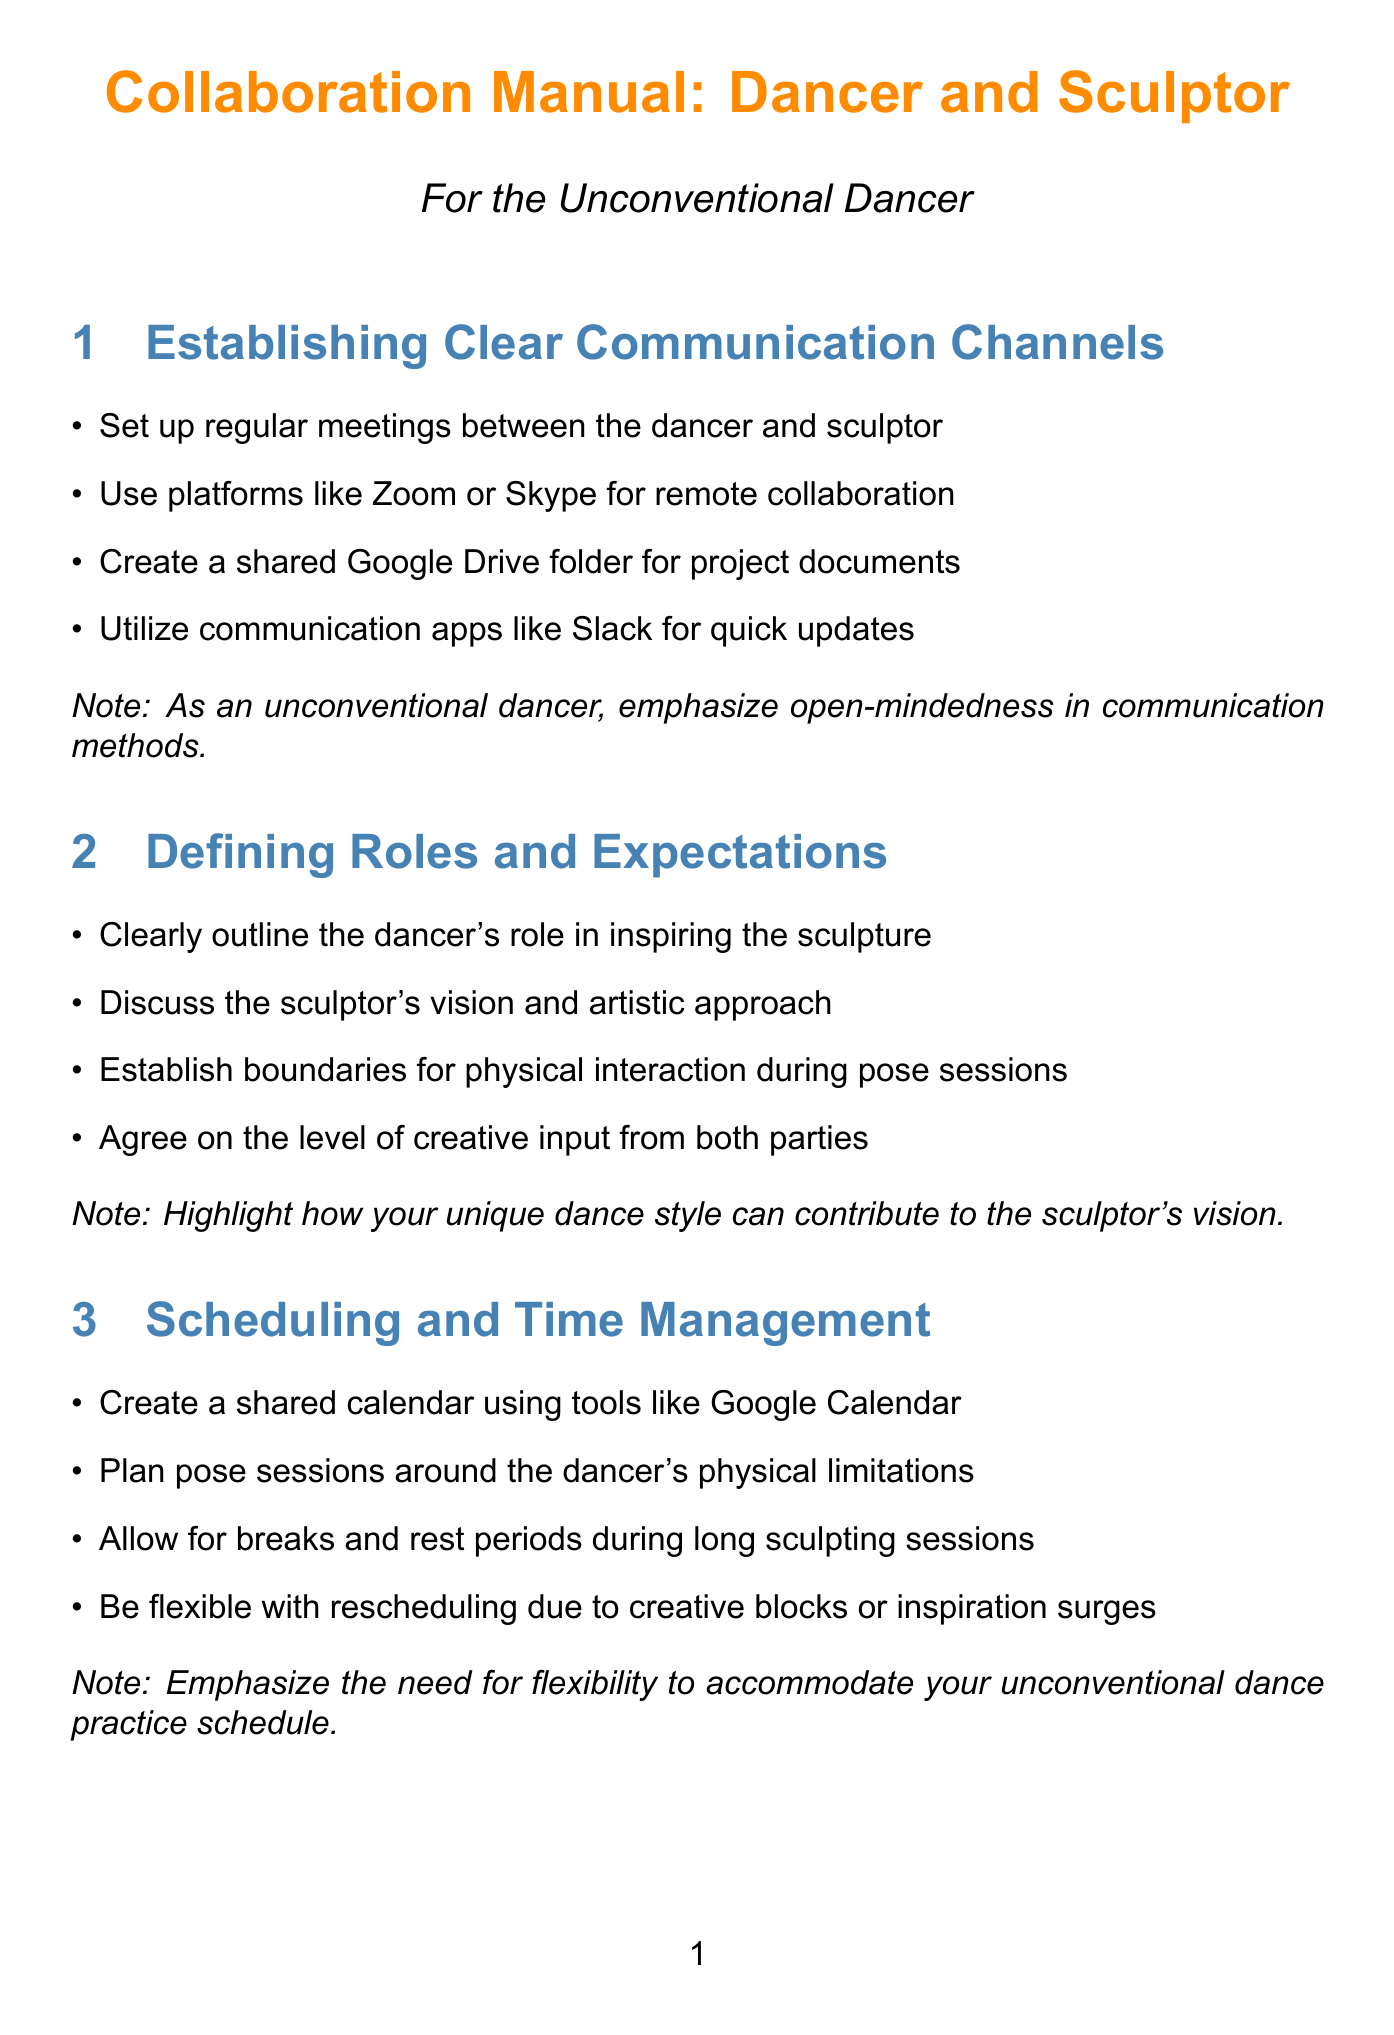what is the title of the manual? The title is explicitly stated at the beginning of the document as the main title.
Answer: Collaboration Manual: Dancer and Sculptor how many sections are in the manual? The total number of sections can be counted by listing them in the document.
Answer: 10 what platform is suggested for remote collaboration? The document lists specific platforms under the communication channels section.
Answer: Zoom what method is recommended for providing feedback? The document specifies a technique for constructive criticism in the relevant section.
Answer: Sandwich method what is emphasized regarding the scheduling of pose sessions? The document outlines important considerations for scheduling sessions specifically for the dancer.
Answer: Physical limitations which tool is suggested for maintaining a shared mood board? The document suggests a specific platform for visual inspiration in the documentation section.
Answer: Pinterest what signal should be established for breaks? The document mentions a specific term to ensure comfort during the physical collaboration.
Answer: Safe word which resources should be provided for emotional support? The manual suggests discussing a type of support resource for emotional challenges.
Answer: Mental health support what should be created to celebrate project completion? The document outlines a specific type of event to acknowledge the end of the collaboration.
Answer: Reveal event how can conflicts be resolved according to the manual? The document offers a general approach to address differing opinions during collaboration.
Answer: Conflict resolution protocol 